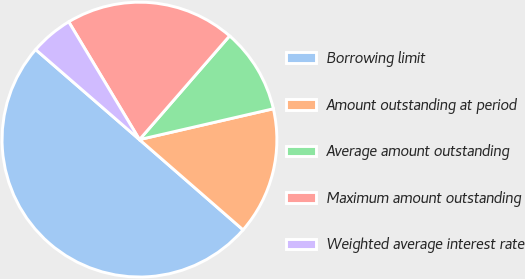<chart> <loc_0><loc_0><loc_500><loc_500><pie_chart><fcel>Borrowing limit<fcel>Amount outstanding at period<fcel>Average amount outstanding<fcel>Maximum amount outstanding<fcel>Weighted average interest rate<nl><fcel>49.97%<fcel>15.01%<fcel>10.01%<fcel>20.0%<fcel>5.02%<nl></chart> 